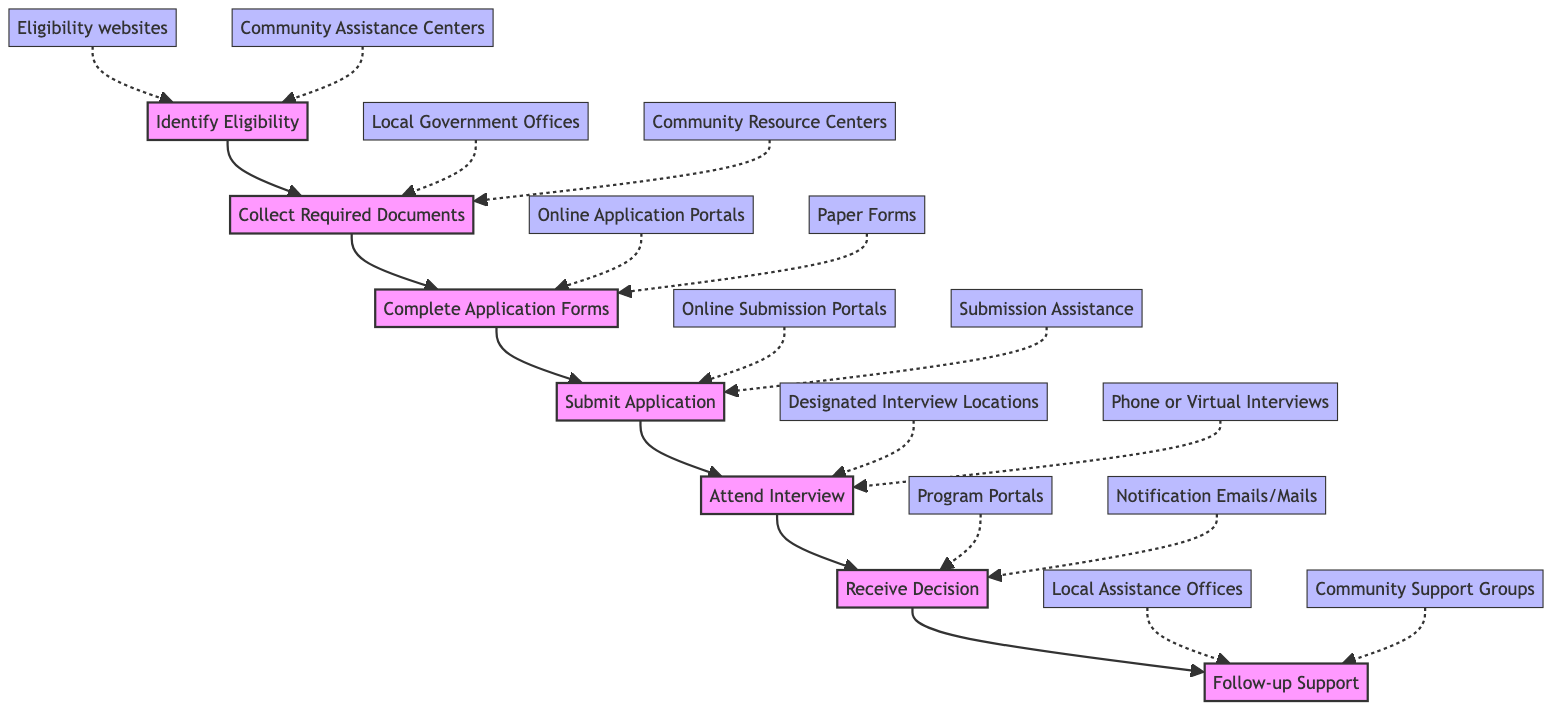What is the first step in the application process? The diagram starts with the node labeled "Identify Eligibility," which indicates the first action to take in the process of applying for public assistance programs.
Answer: Identify Eligibility How many main steps are there in the flow chart? The flow chart contains seven key steps, each represented by a distinct node leading from one to the next.
Answer: Seven What follows the step of "Submit Application"? The next step after "Submit Application" is "Attend Interview," indicating a required follow-up action after the application is submitted.
Answer: Attend Interview Which node provides information about gathering documents? The node "Collect Required Documents" specifically addresses the need to gather necessary documents for the application process.
Answer: Collect Required Documents What is the final step in the flow of this diagram? The final step in the flow of the diagram is "Follow-up Support," which is the last action taken after receiving a decision on the application.
Answer: Follow-up Support How do you submit your application according to the diagram? You can submit your application either online or in person at designated offices, as indicated in the "Submit Application" node.
Answer: Online or in person What resources are available for the "Complete Application Forms" step? The diagram specifies "Online Application Portals" and "Paper Forms from Local Offices" as the resources available for completing application forms.
Answer: Online Application Portals, Paper Forms Which step requires attending an interview? The step labeled "Attend Interview" indicates that this is the action requiring attendance at an interview or follow-up meeting.
Answer: Attend Interview What is the purpose of "Receive Decision" in the flow chart? The purpose of the "Receive Decision" node is to wait for a notification regarding the application status, indicating whether it was successful or not.
Answer: Wait for a decision notification 